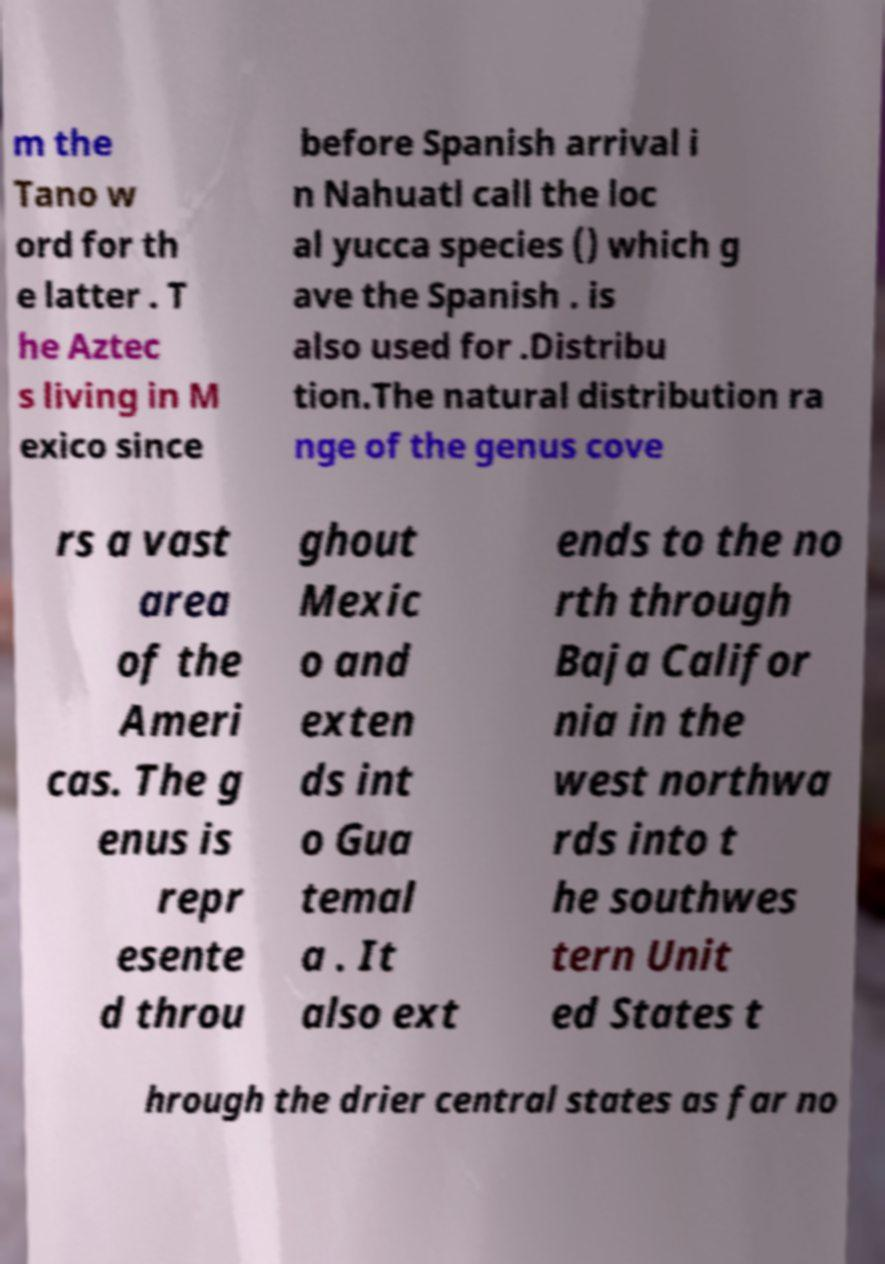Please read and relay the text visible in this image. What does it say? m the Tano w ord for th e latter . T he Aztec s living in M exico since before Spanish arrival i n Nahuatl call the loc al yucca species () which g ave the Spanish . is also used for .Distribu tion.The natural distribution ra nge of the genus cove rs a vast area of the Ameri cas. The g enus is repr esente d throu ghout Mexic o and exten ds int o Gua temal a . It also ext ends to the no rth through Baja Califor nia in the west northwa rds into t he southwes tern Unit ed States t hrough the drier central states as far no 